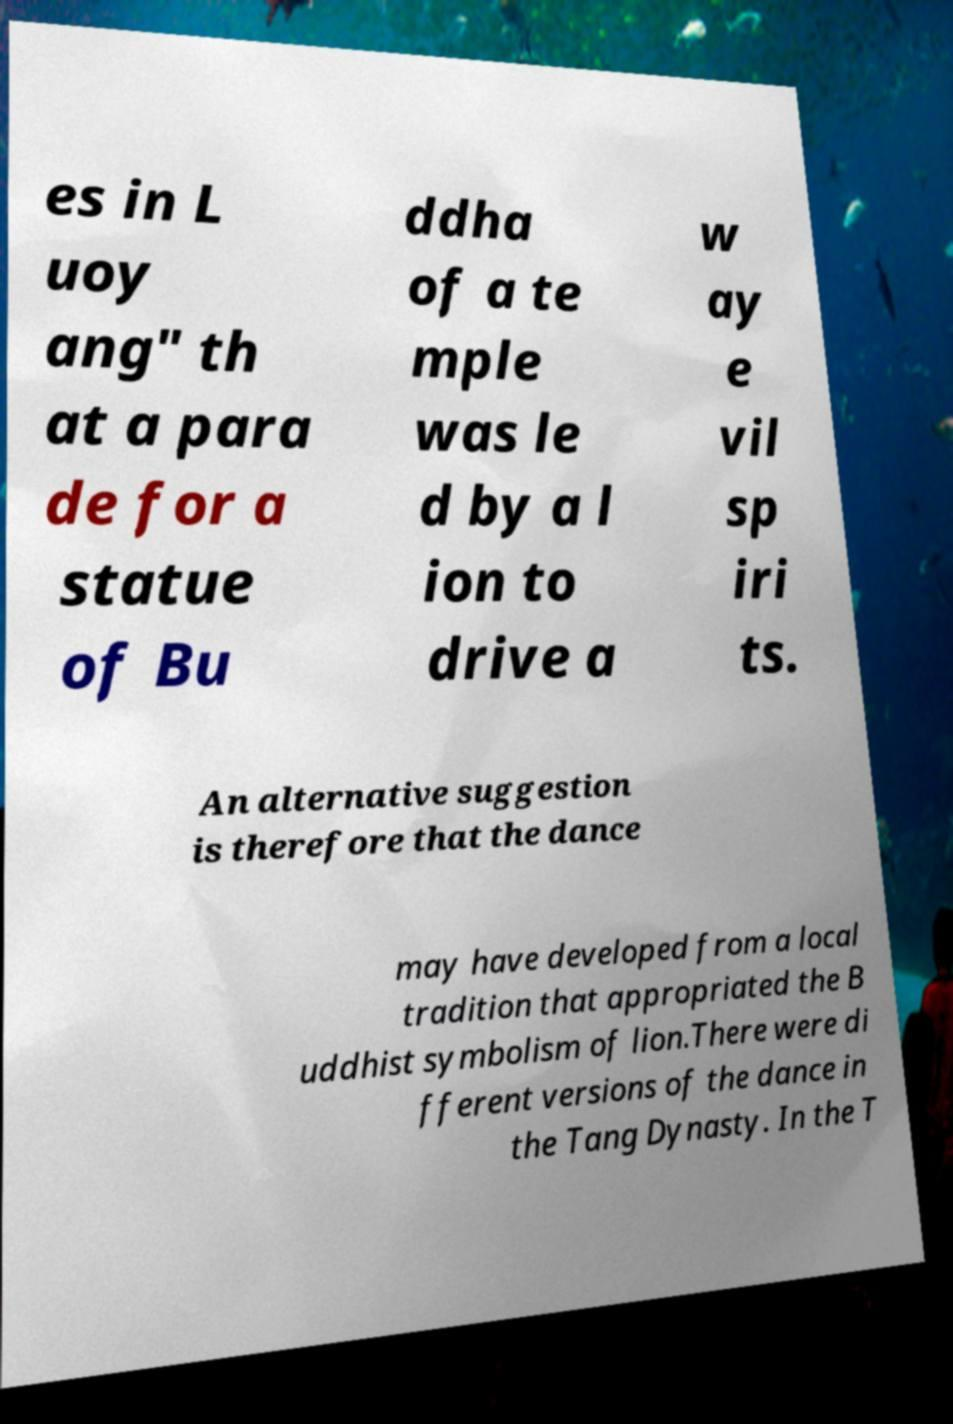Could you extract and type out the text from this image? es in L uoy ang" th at a para de for a statue of Bu ddha of a te mple was le d by a l ion to drive a w ay e vil sp iri ts. An alternative suggestion is therefore that the dance may have developed from a local tradition that appropriated the B uddhist symbolism of lion.There were di fferent versions of the dance in the Tang Dynasty. In the T 